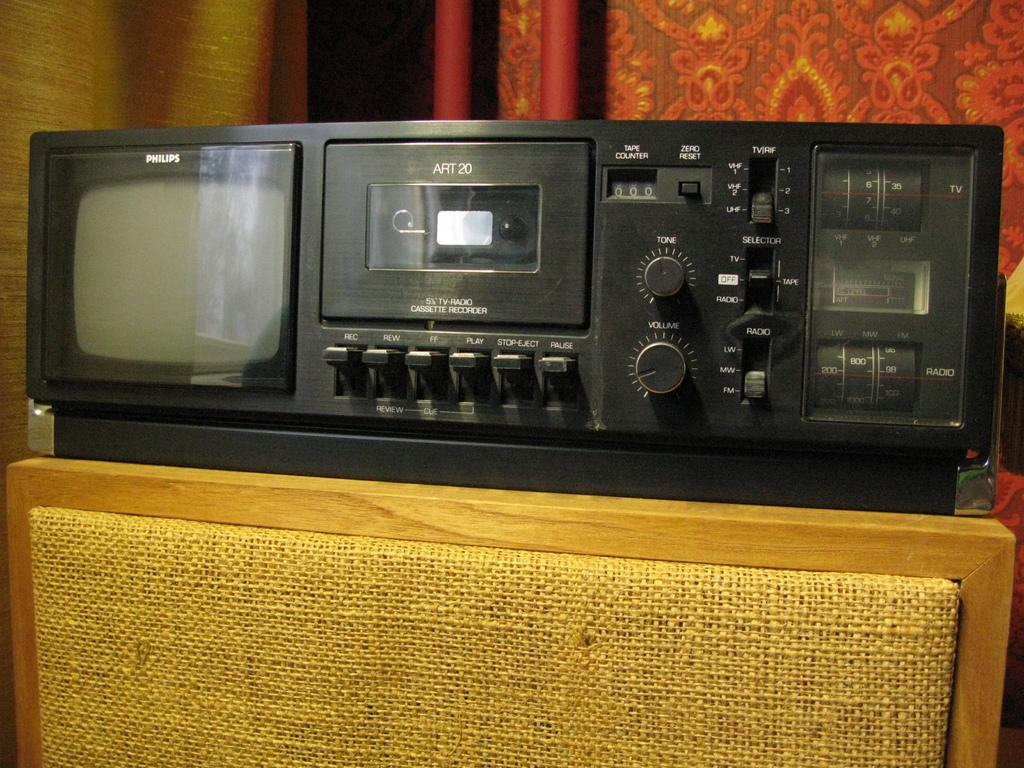What type of object is the main subject in the image? There is an electronic gadget in the image. Where is the electronic gadget placed? The electronic gadget is on a wooden object. What color is the object behind the gadget? There is a red color object behind the gadget. What type of insurance policy is being discussed in the image? There is no discussion of insurance policies in the image; it features an electronic gadget on a wooden object with a red color object behind it. What type of instrument is being played in the image? There is no instrument or music-related activity in the image. 